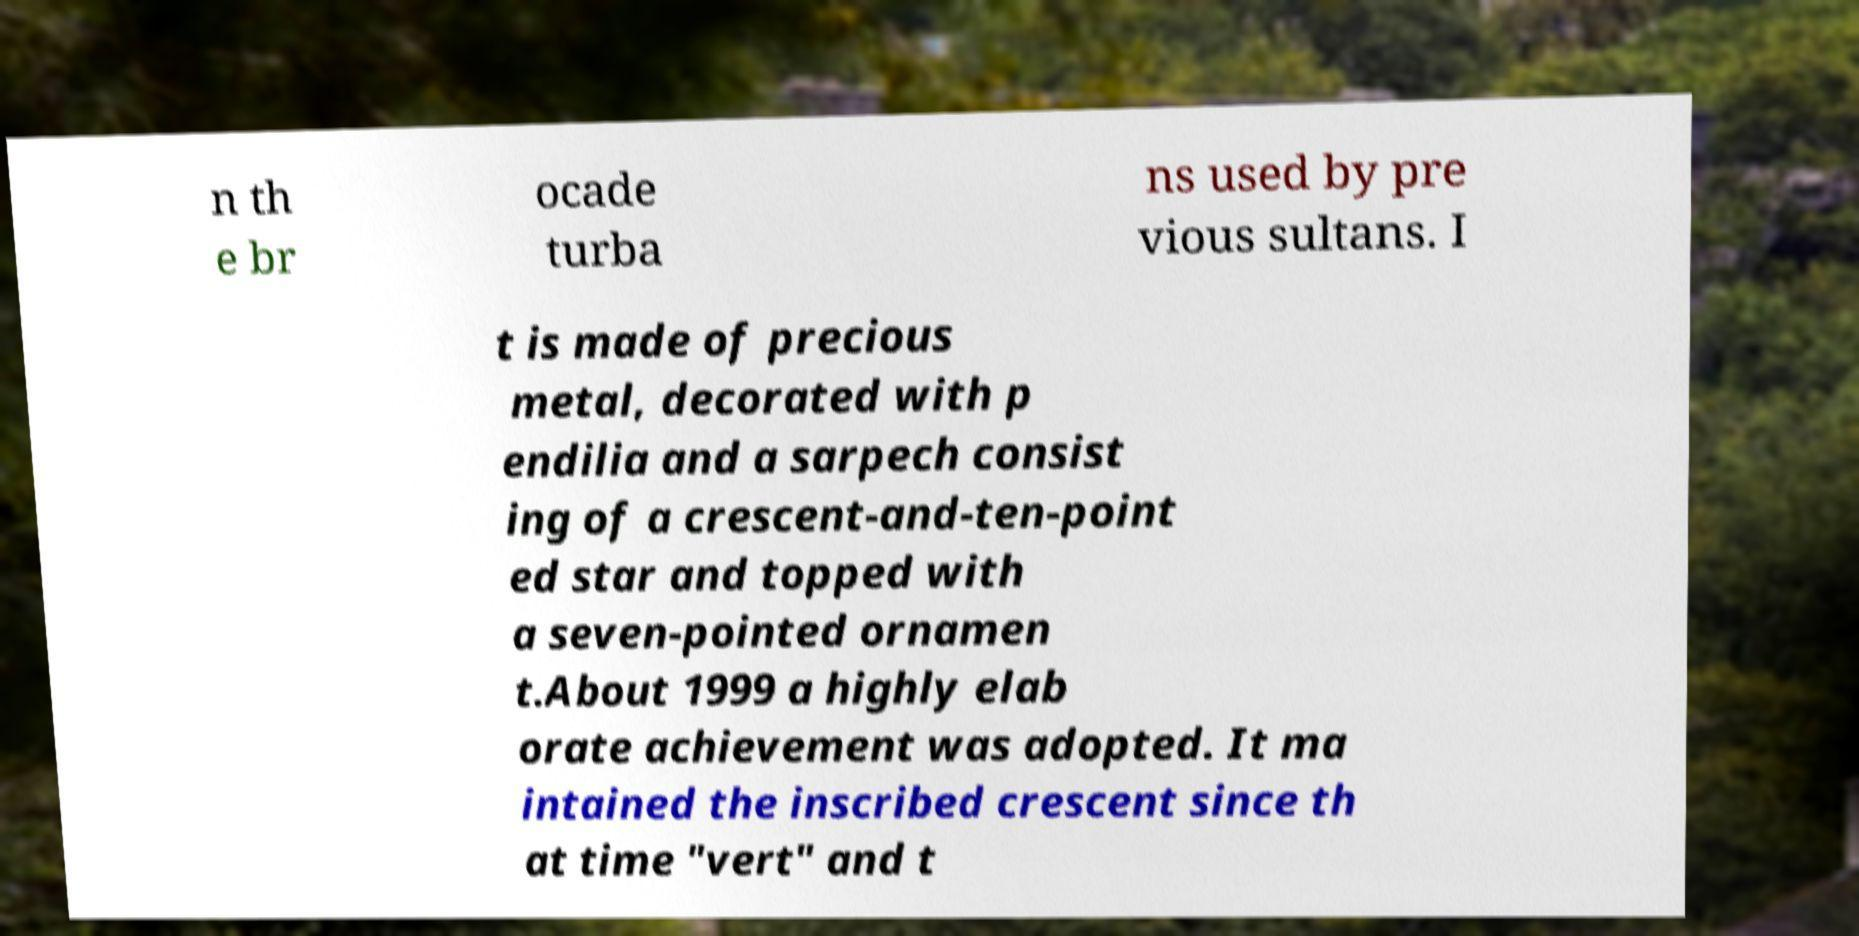Can you read and provide the text displayed in the image?This photo seems to have some interesting text. Can you extract and type it out for me? n th e br ocade turba ns used by pre vious sultans. I t is made of precious metal, decorated with p endilia and a sarpech consist ing of a crescent-and-ten-point ed star and topped with a seven-pointed ornamen t.About 1999 a highly elab orate achievement was adopted. It ma intained the inscribed crescent since th at time "vert" and t 